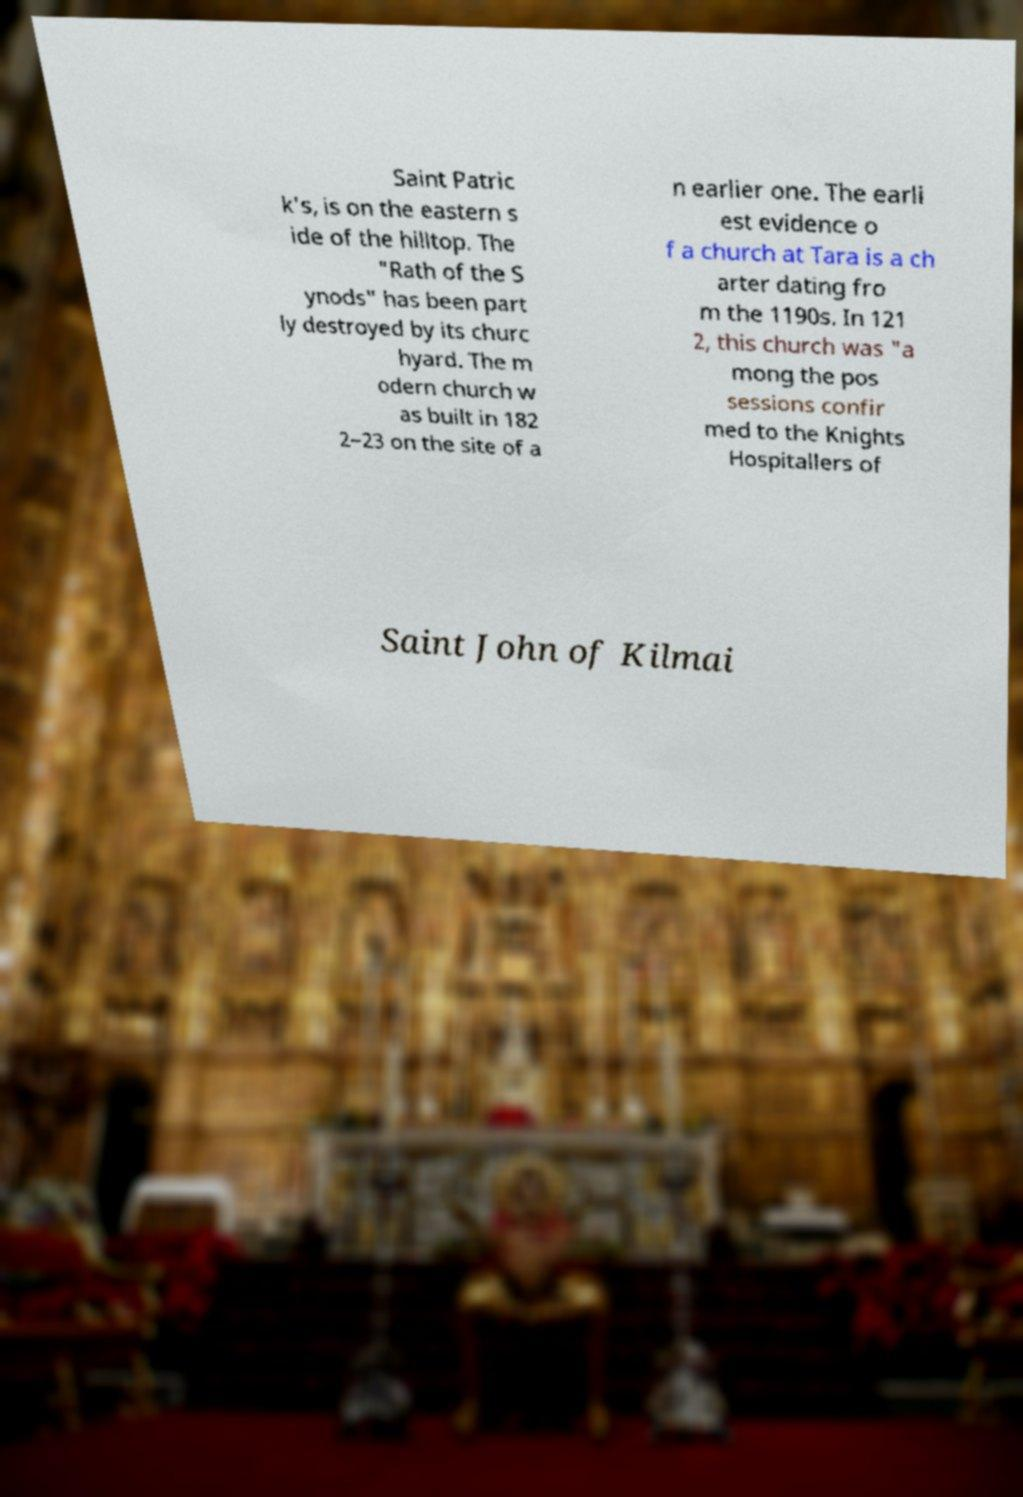What messages or text are displayed in this image? I need them in a readable, typed format. Saint Patric k's, is on the eastern s ide of the hilltop. The "Rath of the S ynods" has been part ly destroyed by its churc hyard. The m odern church w as built in 182 2–23 on the site of a n earlier one. The earli est evidence o f a church at Tara is a ch arter dating fro m the 1190s. In 121 2, this church was "a mong the pos sessions confir med to the Knights Hospitallers of Saint John of Kilmai 